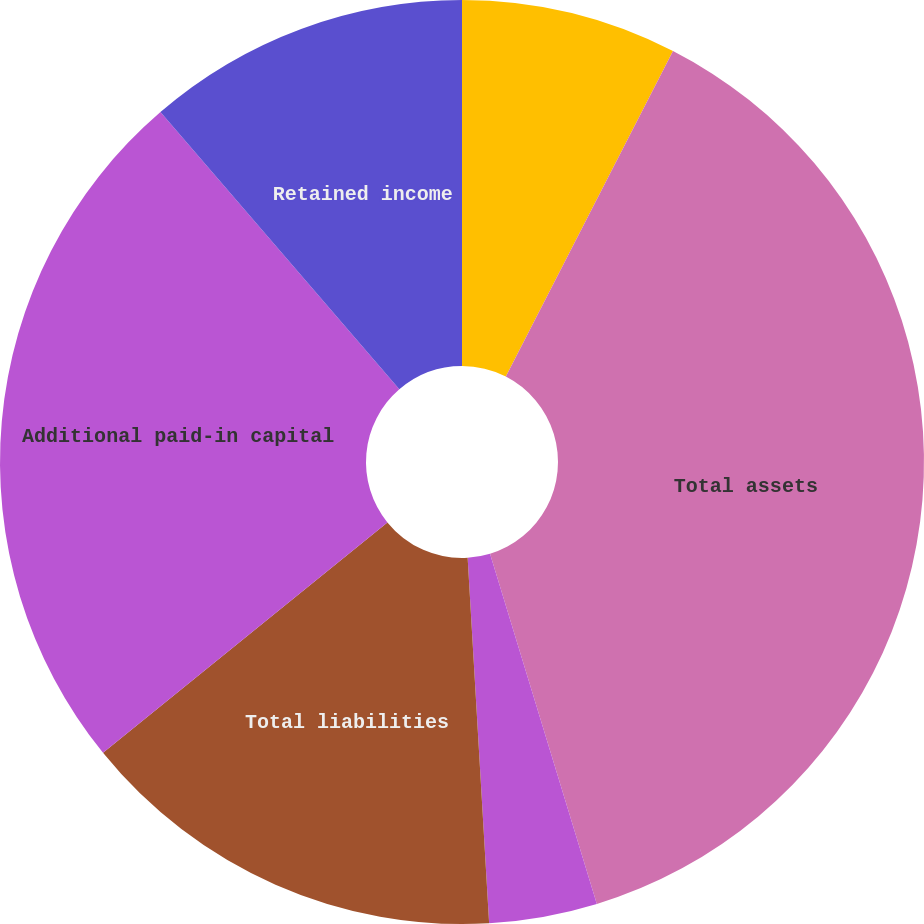Convert chart. <chart><loc_0><loc_0><loc_500><loc_500><pie_chart><fcel>Prepaid and other current<fcel>Total current assets<fcel>Total assets<fcel>Total current liabilities<fcel>Total liabilities<fcel>Additional paid-in capital<fcel>Retained income<nl><fcel>0.0%<fcel>7.55%<fcel>37.74%<fcel>3.78%<fcel>15.1%<fcel>24.52%<fcel>11.32%<nl></chart> 